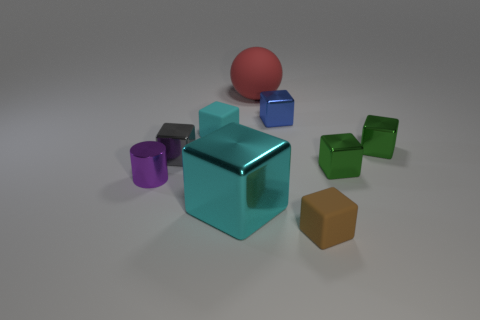There is a rubber thing that is the same color as the big shiny object; what shape is it?
Your answer should be compact. Cube. How many blue things have the same size as the cyan metal block?
Offer a very short reply. 0. Do the red matte thing and the purple thing have the same shape?
Your answer should be very brief. No. What color is the small matte object that is to the left of the rubber thing in front of the gray metallic thing?
Ensure brevity in your answer.  Cyan. How big is the thing that is in front of the tiny purple metallic object and left of the tiny brown block?
Give a very brief answer. Large. Is there anything else that has the same color as the big matte ball?
Provide a succinct answer. No. What shape is the purple object that is made of the same material as the gray thing?
Provide a short and direct response. Cylinder. There is a tiny purple metal object; is it the same shape as the blue metal thing that is to the right of the small purple cylinder?
Your response must be concise. No. What material is the green block behind the tiny shiny block to the left of the small blue metal thing?
Your answer should be very brief. Metal. Are there an equal number of blue things behind the large red object and red matte things?
Your response must be concise. No. 